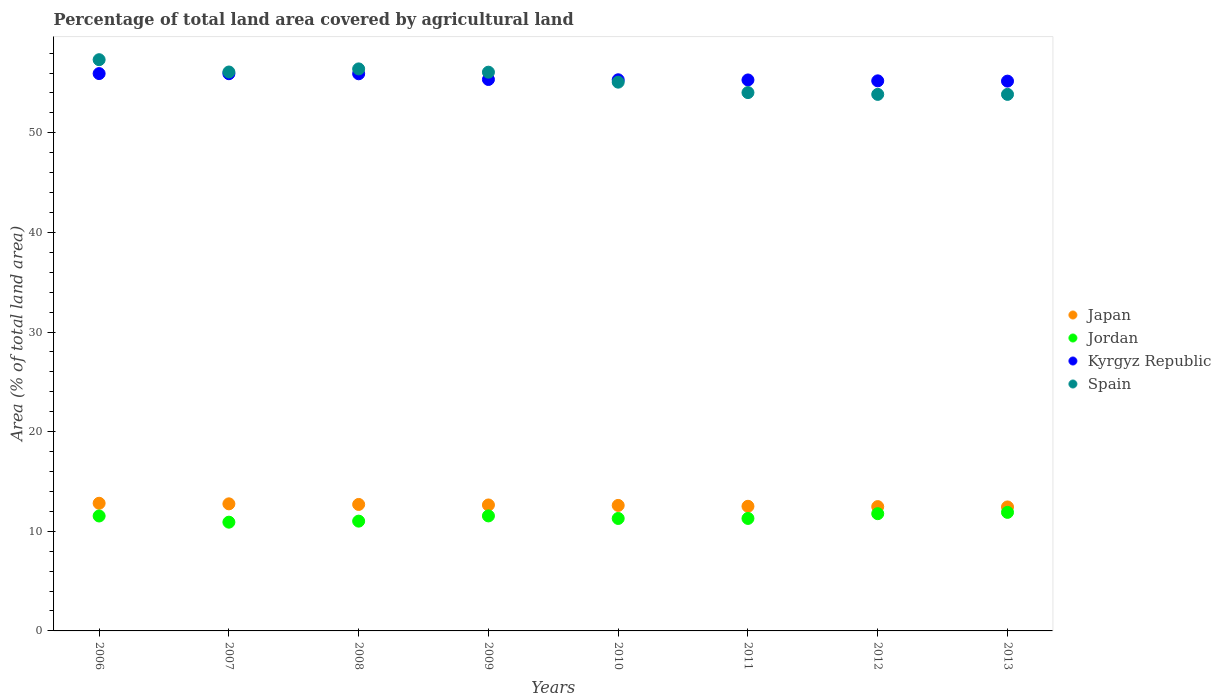Is the number of dotlines equal to the number of legend labels?
Offer a terse response. Yes. What is the percentage of agricultural land in Jordan in 2009?
Your response must be concise. 11.55. Across all years, what is the maximum percentage of agricultural land in Spain?
Ensure brevity in your answer.  57.34. Across all years, what is the minimum percentage of agricultural land in Japan?
Offer a very short reply. 12.45. In which year was the percentage of agricultural land in Jordan maximum?
Offer a terse response. 2013. In which year was the percentage of agricultural land in Jordan minimum?
Provide a short and direct response. 2007. What is the total percentage of agricultural land in Jordan in the graph?
Your response must be concise. 91.27. What is the difference between the percentage of agricultural land in Kyrgyz Republic in 2009 and that in 2012?
Your response must be concise. 0.14. What is the difference between the percentage of agricultural land in Jordan in 2011 and the percentage of agricultural land in Spain in 2008?
Offer a terse response. -45.13. What is the average percentage of agricultural land in Jordan per year?
Offer a terse response. 11.41. In the year 2007, what is the difference between the percentage of agricultural land in Spain and percentage of agricultural land in Jordan?
Offer a terse response. 45.19. In how many years, is the percentage of agricultural land in Jordan greater than 18 %?
Offer a terse response. 0. What is the ratio of the percentage of agricultural land in Jordan in 2009 to that in 2012?
Provide a succinct answer. 0.98. Is the percentage of agricultural land in Jordan in 2011 less than that in 2012?
Provide a succinct answer. Yes. Is the difference between the percentage of agricultural land in Spain in 2010 and 2012 greater than the difference between the percentage of agricultural land in Jordan in 2010 and 2012?
Offer a very short reply. Yes. What is the difference between the highest and the second highest percentage of agricultural land in Kyrgyz Republic?
Offer a very short reply. 0.01. What is the difference between the highest and the lowest percentage of agricultural land in Japan?
Provide a short and direct response. 0.37. Is it the case that in every year, the sum of the percentage of agricultural land in Jordan and percentage of agricultural land in Spain  is greater than the percentage of agricultural land in Kyrgyz Republic?
Offer a very short reply. Yes. Does the percentage of agricultural land in Jordan monotonically increase over the years?
Your answer should be very brief. No. Is the percentage of agricultural land in Spain strictly less than the percentage of agricultural land in Japan over the years?
Provide a succinct answer. No. How many years are there in the graph?
Offer a terse response. 8. Does the graph contain grids?
Your answer should be very brief. No. What is the title of the graph?
Make the answer very short. Percentage of total land area covered by agricultural land. Does "Seychelles" appear as one of the legend labels in the graph?
Give a very brief answer. No. What is the label or title of the Y-axis?
Make the answer very short. Area (% of total land area). What is the Area (% of total land area) of Japan in 2006?
Give a very brief answer. 12.81. What is the Area (% of total land area) of Jordan in 2006?
Offer a very short reply. 11.54. What is the Area (% of total land area) in Kyrgyz Republic in 2006?
Provide a succinct answer. 55.95. What is the Area (% of total land area) in Spain in 2006?
Provide a succinct answer. 57.34. What is the Area (% of total land area) of Japan in 2007?
Make the answer very short. 12.76. What is the Area (% of total land area) of Jordan in 2007?
Offer a terse response. 10.92. What is the Area (% of total land area) of Kyrgyz Republic in 2007?
Your answer should be compact. 55.94. What is the Area (% of total land area) of Spain in 2007?
Provide a succinct answer. 56.11. What is the Area (% of total land area) of Japan in 2008?
Your answer should be very brief. 12.7. What is the Area (% of total land area) of Jordan in 2008?
Your response must be concise. 11.02. What is the Area (% of total land area) in Kyrgyz Republic in 2008?
Provide a short and direct response. 55.93. What is the Area (% of total land area) in Spain in 2008?
Give a very brief answer. 56.42. What is the Area (% of total land area) of Japan in 2009?
Provide a succinct answer. 12.64. What is the Area (% of total land area) of Jordan in 2009?
Ensure brevity in your answer.  11.55. What is the Area (% of total land area) of Kyrgyz Republic in 2009?
Ensure brevity in your answer.  55.36. What is the Area (% of total land area) of Spain in 2009?
Your answer should be compact. 56.09. What is the Area (% of total land area) in Japan in 2010?
Give a very brief answer. 12.6. What is the Area (% of total land area) in Jordan in 2010?
Provide a succinct answer. 11.29. What is the Area (% of total land area) in Kyrgyz Republic in 2010?
Give a very brief answer. 55.33. What is the Area (% of total land area) of Spain in 2010?
Make the answer very short. 55.09. What is the Area (% of total land area) in Japan in 2011?
Your answer should be compact. 12.51. What is the Area (% of total land area) of Jordan in 2011?
Your response must be concise. 11.29. What is the Area (% of total land area) in Kyrgyz Republic in 2011?
Your answer should be very brief. 55.31. What is the Area (% of total land area) of Spain in 2011?
Provide a short and direct response. 54.04. What is the Area (% of total land area) in Japan in 2012?
Your answer should be compact. 12.48. What is the Area (% of total land area) of Jordan in 2012?
Your answer should be compact. 11.77. What is the Area (% of total land area) of Kyrgyz Republic in 2012?
Provide a short and direct response. 55.22. What is the Area (% of total land area) of Spain in 2012?
Offer a terse response. 53.86. What is the Area (% of total land area) of Japan in 2013?
Offer a terse response. 12.45. What is the Area (% of total land area) in Jordan in 2013?
Keep it short and to the point. 11.9. What is the Area (% of total land area) in Kyrgyz Republic in 2013?
Provide a short and direct response. 55.19. What is the Area (% of total land area) of Spain in 2013?
Your answer should be very brief. 53.86. Across all years, what is the maximum Area (% of total land area) of Japan?
Provide a succinct answer. 12.81. Across all years, what is the maximum Area (% of total land area) of Jordan?
Keep it short and to the point. 11.9. Across all years, what is the maximum Area (% of total land area) in Kyrgyz Republic?
Make the answer very short. 55.95. Across all years, what is the maximum Area (% of total land area) in Spain?
Offer a terse response. 57.34. Across all years, what is the minimum Area (% of total land area) in Japan?
Ensure brevity in your answer.  12.45. Across all years, what is the minimum Area (% of total land area) in Jordan?
Your response must be concise. 10.92. Across all years, what is the minimum Area (% of total land area) in Kyrgyz Republic?
Ensure brevity in your answer.  55.19. Across all years, what is the minimum Area (% of total land area) of Spain?
Your response must be concise. 53.86. What is the total Area (% of total land area) of Japan in the graph?
Offer a terse response. 100.95. What is the total Area (% of total land area) in Jordan in the graph?
Your answer should be very brief. 91.27. What is the total Area (% of total land area) of Kyrgyz Republic in the graph?
Offer a very short reply. 444.22. What is the total Area (% of total land area) in Spain in the graph?
Your answer should be compact. 442.81. What is the difference between the Area (% of total land area) in Japan in 2006 and that in 2007?
Provide a succinct answer. 0.06. What is the difference between the Area (% of total land area) in Jordan in 2006 and that in 2007?
Your answer should be compact. 0.62. What is the difference between the Area (% of total land area) of Kyrgyz Republic in 2006 and that in 2007?
Provide a short and direct response. 0.01. What is the difference between the Area (% of total land area) in Spain in 2006 and that in 2007?
Provide a succinct answer. 1.24. What is the difference between the Area (% of total land area) in Japan in 2006 and that in 2008?
Your response must be concise. 0.12. What is the difference between the Area (% of total land area) in Jordan in 2006 and that in 2008?
Keep it short and to the point. 0.52. What is the difference between the Area (% of total land area) of Kyrgyz Republic in 2006 and that in 2008?
Provide a short and direct response. 0.02. What is the difference between the Area (% of total land area) in Spain in 2006 and that in 2008?
Your response must be concise. 0.92. What is the difference between the Area (% of total land area) in Japan in 2006 and that in 2009?
Offer a terse response. 0.17. What is the difference between the Area (% of total land area) in Jordan in 2006 and that in 2009?
Your answer should be compact. -0.01. What is the difference between the Area (% of total land area) in Kyrgyz Republic in 2006 and that in 2009?
Give a very brief answer. 0.59. What is the difference between the Area (% of total land area) in Spain in 2006 and that in 2009?
Give a very brief answer. 1.25. What is the difference between the Area (% of total land area) of Japan in 2006 and that in 2010?
Offer a terse response. 0.22. What is the difference between the Area (% of total land area) of Jordan in 2006 and that in 2010?
Make the answer very short. 0.25. What is the difference between the Area (% of total land area) of Kyrgyz Republic in 2006 and that in 2010?
Offer a terse response. 0.62. What is the difference between the Area (% of total land area) in Spain in 2006 and that in 2010?
Provide a succinct answer. 2.25. What is the difference between the Area (% of total land area) of Japan in 2006 and that in 2011?
Your answer should be compact. 0.3. What is the difference between the Area (% of total land area) of Jordan in 2006 and that in 2011?
Keep it short and to the point. 0.24. What is the difference between the Area (% of total land area) in Kyrgyz Republic in 2006 and that in 2011?
Your response must be concise. 0.64. What is the difference between the Area (% of total land area) in Spain in 2006 and that in 2011?
Your answer should be very brief. 3.3. What is the difference between the Area (% of total land area) in Japan in 2006 and that in 2012?
Keep it short and to the point. 0.34. What is the difference between the Area (% of total land area) in Jordan in 2006 and that in 2012?
Keep it short and to the point. -0.23. What is the difference between the Area (% of total land area) of Kyrgyz Republic in 2006 and that in 2012?
Keep it short and to the point. 0.73. What is the difference between the Area (% of total land area) of Spain in 2006 and that in 2012?
Your answer should be very brief. 3.48. What is the difference between the Area (% of total land area) of Japan in 2006 and that in 2013?
Provide a short and direct response. 0.37. What is the difference between the Area (% of total land area) in Jordan in 2006 and that in 2013?
Offer a terse response. -0.36. What is the difference between the Area (% of total land area) of Kyrgyz Republic in 2006 and that in 2013?
Your answer should be compact. 0.76. What is the difference between the Area (% of total land area) in Spain in 2006 and that in 2013?
Offer a very short reply. 3.48. What is the difference between the Area (% of total land area) in Japan in 2007 and that in 2008?
Ensure brevity in your answer.  0.06. What is the difference between the Area (% of total land area) of Jordan in 2007 and that in 2008?
Keep it short and to the point. -0.1. What is the difference between the Area (% of total land area) in Kyrgyz Republic in 2007 and that in 2008?
Make the answer very short. 0.01. What is the difference between the Area (% of total land area) in Spain in 2007 and that in 2008?
Offer a terse response. -0.31. What is the difference between the Area (% of total land area) in Japan in 2007 and that in 2009?
Give a very brief answer. 0.11. What is the difference between the Area (% of total land area) in Jordan in 2007 and that in 2009?
Provide a short and direct response. -0.63. What is the difference between the Area (% of total land area) in Kyrgyz Republic in 2007 and that in 2009?
Your answer should be compact. 0.58. What is the difference between the Area (% of total land area) in Spain in 2007 and that in 2009?
Your answer should be compact. 0.02. What is the difference between the Area (% of total land area) in Japan in 2007 and that in 2010?
Your answer should be very brief. 0.16. What is the difference between the Area (% of total land area) of Jordan in 2007 and that in 2010?
Your answer should be very brief. -0.37. What is the difference between the Area (% of total land area) of Kyrgyz Republic in 2007 and that in 2010?
Offer a terse response. 0.61. What is the difference between the Area (% of total land area) of Japan in 2007 and that in 2011?
Your answer should be compact. 0.25. What is the difference between the Area (% of total land area) of Jordan in 2007 and that in 2011?
Your response must be concise. -0.38. What is the difference between the Area (% of total land area) of Kyrgyz Republic in 2007 and that in 2011?
Give a very brief answer. 0.63. What is the difference between the Area (% of total land area) in Spain in 2007 and that in 2011?
Your answer should be very brief. 2.07. What is the difference between the Area (% of total land area) in Japan in 2007 and that in 2012?
Provide a succinct answer. 0.28. What is the difference between the Area (% of total land area) of Jordan in 2007 and that in 2012?
Provide a short and direct response. -0.85. What is the difference between the Area (% of total land area) of Kyrgyz Republic in 2007 and that in 2012?
Your answer should be very brief. 0.72. What is the difference between the Area (% of total land area) in Spain in 2007 and that in 2012?
Give a very brief answer. 2.25. What is the difference between the Area (% of total land area) of Japan in 2007 and that in 2013?
Ensure brevity in your answer.  0.31. What is the difference between the Area (% of total land area) in Jordan in 2007 and that in 2013?
Provide a succinct answer. -0.98. What is the difference between the Area (% of total land area) in Kyrgyz Republic in 2007 and that in 2013?
Provide a short and direct response. 0.74. What is the difference between the Area (% of total land area) of Spain in 2007 and that in 2013?
Provide a short and direct response. 2.25. What is the difference between the Area (% of total land area) of Japan in 2008 and that in 2009?
Give a very brief answer. 0.05. What is the difference between the Area (% of total land area) of Jordan in 2008 and that in 2009?
Offer a terse response. -0.52. What is the difference between the Area (% of total land area) of Kyrgyz Republic in 2008 and that in 2009?
Offer a terse response. 0.57. What is the difference between the Area (% of total land area) in Spain in 2008 and that in 2009?
Provide a succinct answer. 0.33. What is the difference between the Area (% of total land area) of Japan in 2008 and that in 2010?
Offer a terse response. 0.1. What is the difference between the Area (% of total land area) of Jordan in 2008 and that in 2010?
Give a very brief answer. -0.27. What is the difference between the Area (% of total land area) of Kyrgyz Republic in 2008 and that in 2010?
Offer a terse response. 0.6. What is the difference between the Area (% of total land area) in Spain in 2008 and that in 2010?
Ensure brevity in your answer.  1.33. What is the difference between the Area (% of total land area) in Japan in 2008 and that in 2011?
Provide a succinct answer. 0.19. What is the difference between the Area (% of total land area) in Jordan in 2008 and that in 2011?
Provide a succinct answer. -0.27. What is the difference between the Area (% of total land area) of Kyrgyz Republic in 2008 and that in 2011?
Your answer should be very brief. 0.62. What is the difference between the Area (% of total land area) of Spain in 2008 and that in 2011?
Keep it short and to the point. 2.38. What is the difference between the Area (% of total land area) of Japan in 2008 and that in 2012?
Provide a short and direct response. 0.22. What is the difference between the Area (% of total land area) in Jordan in 2008 and that in 2012?
Offer a very short reply. -0.75. What is the difference between the Area (% of total land area) in Kyrgyz Republic in 2008 and that in 2012?
Your answer should be compact. 0.71. What is the difference between the Area (% of total land area) in Spain in 2008 and that in 2012?
Keep it short and to the point. 2.56. What is the difference between the Area (% of total land area) in Japan in 2008 and that in 2013?
Offer a very short reply. 0.25. What is the difference between the Area (% of total land area) in Jordan in 2008 and that in 2013?
Your answer should be compact. -0.88. What is the difference between the Area (% of total land area) of Kyrgyz Republic in 2008 and that in 2013?
Ensure brevity in your answer.  0.74. What is the difference between the Area (% of total land area) of Spain in 2008 and that in 2013?
Provide a short and direct response. 2.56. What is the difference between the Area (% of total land area) of Japan in 2009 and that in 2010?
Offer a terse response. 0.05. What is the difference between the Area (% of total land area) of Jordan in 2009 and that in 2010?
Give a very brief answer. 0.26. What is the difference between the Area (% of total land area) of Kyrgyz Republic in 2009 and that in 2010?
Offer a very short reply. 0.03. What is the difference between the Area (% of total land area) in Japan in 2009 and that in 2011?
Your answer should be compact. 0.13. What is the difference between the Area (% of total land area) in Jordan in 2009 and that in 2011?
Ensure brevity in your answer.  0.25. What is the difference between the Area (% of total land area) of Kyrgyz Republic in 2009 and that in 2011?
Provide a succinct answer. 0.05. What is the difference between the Area (% of total land area) in Spain in 2009 and that in 2011?
Your response must be concise. 2.05. What is the difference between the Area (% of total land area) in Japan in 2009 and that in 2012?
Give a very brief answer. 0.17. What is the difference between the Area (% of total land area) of Jordan in 2009 and that in 2012?
Offer a very short reply. -0.22. What is the difference between the Area (% of total land area) of Kyrgyz Republic in 2009 and that in 2012?
Provide a succinct answer. 0.14. What is the difference between the Area (% of total land area) in Spain in 2009 and that in 2012?
Provide a succinct answer. 2.23. What is the difference between the Area (% of total land area) of Japan in 2009 and that in 2013?
Your response must be concise. 0.2. What is the difference between the Area (% of total land area) in Jordan in 2009 and that in 2013?
Make the answer very short. -0.36. What is the difference between the Area (% of total land area) of Kyrgyz Republic in 2009 and that in 2013?
Your response must be concise. 0.16. What is the difference between the Area (% of total land area) of Spain in 2009 and that in 2013?
Provide a short and direct response. 2.23. What is the difference between the Area (% of total land area) of Japan in 2010 and that in 2011?
Your answer should be compact. 0.09. What is the difference between the Area (% of total land area) in Jordan in 2010 and that in 2011?
Give a very brief answer. -0. What is the difference between the Area (% of total land area) of Kyrgyz Republic in 2010 and that in 2011?
Keep it short and to the point. 0.02. What is the difference between the Area (% of total land area) in Spain in 2010 and that in 2011?
Your answer should be very brief. 1.05. What is the difference between the Area (% of total land area) of Japan in 2010 and that in 2012?
Offer a very short reply. 0.12. What is the difference between the Area (% of total land area) in Jordan in 2010 and that in 2012?
Offer a terse response. -0.48. What is the difference between the Area (% of total land area) in Kyrgyz Republic in 2010 and that in 2012?
Make the answer very short. 0.11. What is the difference between the Area (% of total land area) in Spain in 2010 and that in 2012?
Keep it short and to the point. 1.23. What is the difference between the Area (% of total land area) in Japan in 2010 and that in 2013?
Ensure brevity in your answer.  0.15. What is the difference between the Area (% of total land area) in Jordan in 2010 and that in 2013?
Your answer should be compact. -0.61. What is the difference between the Area (% of total land area) in Kyrgyz Republic in 2010 and that in 2013?
Keep it short and to the point. 0.14. What is the difference between the Area (% of total land area) in Spain in 2010 and that in 2013?
Offer a very short reply. 1.23. What is the difference between the Area (% of total land area) of Japan in 2011 and that in 2012?
Make the answer very short. 0.03. What is the difference between the Area (% of total land area) of Jordan in 2011 and that in 2012?
Make the answer very short. -0.48. What is the difference between the Area (% of total land area) in Kyrgyz Republic in 2011 and that in 2012?
Provide a succinct answer. 0.09. What is the difference between the Area (% of total land area) of Spain in 2011 and that in 2012?
Offer a terse response. 0.18. What is the difference between the Area (% of total land area) in Japan in 2011 and that in 2013?
Make the answer very short. 0.07. What is the difference between the Area (% of total land area) in Jordan in 2011 and that in 2013?
Offer a very short reply. -0.61. What is the difference between the Area (% of total land area) of Kyrgyz Republic in 2011 and that in 2013?
Offer a terse response. 0.12. What is the difference between the Area (% of total land area) in Spain in 2011 and that in 2013?
Ensure brevity in your answer.  0.18. What is the difference between the Area (% of total land area) of Japan in 2012 and that in 2013?
Your response must be concise. 0.03. What is the difference between the Area (% of total land area) in Jordan in 2012 and that in 2013?
Offer a terse response. -0.13. What is the difference between the Area (% of total land area) of Kyrgyz Republic in 2012 and that in 2013?
Keep it short and to the point. 0.03. What is the difference between the Area (% of total land area) in Japan in 2006 and the Area (% of total land area) in Jordan in 2007?
Offer a terse response. 1.9. What is the difference between the Area (% of total land area) of Japan in 2006 and the Area (% of total land area) of Kyrgyz Republic in 2007?
Your response must be concise. -43.12. What is the difference between the Area (% of total land area) in Japan in 2006 and the Area (% of total land area) in Spain in 2007?
Your answer should be very brief. -43.29. What is the difference between the Area (% of total land area) in Jordan in 2006 and the Area (% of total land area) in Kyrgyz Republic in 2007?
Provide a short and direct response. -44.4. What is the difference between the Area (% of total land area) of Jordan in 2006 and the Area (% of total land area) of Spain in 2007?
Your response must be concise. -44.57. What is the difference between the Area (% of total land area) of Kyrgyz Republic in 2006 and the Area (% of total land area) of Spain in 2007?
Give a very brief answer. -0.16. What is the difference between the Area (% of total land area) of Japan in 2006 and the Area (% of total land area) of Jordan in 2008?
Offer a terse response. 1.79. What is the difference between the Area (% of total land area) of Japan in 2006 and the Area (% of total land area) of Kyrgyz Republic in 2008?
Give a very brief answer. -43.11. What is the difference between the Area (% of total land area) in Japan in 2006 and the Area (% of total land area) in Spain in 2008?
Provide a short and direct response. -43.6. What is the difference between the Area (% of total land area) of Jordan in 2006 and the Area (% of total land area) of Kyrgyz Republic in 2008?
Ensure brevity in your answer.  -44.39. What is the difference between the Area (% of total land area) of Jordan in 2006 and the Area (% of total land area) of Spain in 2008?
Make the answer very short. -44.88. What is the difference between the Area (% of total land area) in Kyrgyz Republic in 2006 and the Area (% of total land area) in Spain in 2008?
Your response must be concise. -0.47. What is the difference between the Area (% of total land area) in Japan in 2006 and the Area (% of total land area) in Jordan in 2009?
Make the answer very short. 1.27. What is the difference between the Area (% of total land area) in Japan in 2006 and the Area (% of total land area) in Kyrgyz Republic in 2009?
Ensure brevity in your answer.  -42.54. What is the difference between the Area (% of total land area) of Japan in 2006 and the Area (% of total land area) of Spain in 2009?
Provide a succinct answer. -43.28. What is the difference between the Area (% of total land area) in Jordan in 2006 and the Area (% of total land area) in Kyrgyz Republic in 2009?
Provide a succinct answer. -43.82. What is the difference between the Area (% of total land area) in Jordan in 2006 and the Area (% of total land area) in Spain in 2009?
Your answer should be compact. -44.55. What is the difference between the Area (% of total land area) of Kyrgyz Republic in 2006 and the Area (% of total land area) of Spain in 2009?
Make the answer very short. -0.14. What is the difference between the Area (% of total land area) of Japan in 2006 and the Area (% of total land area) of Jordan in 2010?
Offer a very short reply. 1.53. What is the difference between the Area (% of total land area) in Japan in 2006 and the Area (% of total land area) in Kyrgyz Republic in 2010?
Provide a succinct answer. -42.51. What is the difference between the Area (% of total land area) in Japan in 2006 and the Area (% of total land area) in Spain in 2010?
Offer a very short reply. -42.27. What is the difference between the Area (% of total land area) of Jordan in 2006 and the Area (% of total land area) of Kyrgyz Republic in 2010?
Ensure brevity in your answer.  -43.79. What is the difference between the Area (% of total land area) in Jordan in 2006 and the Area (% of total land area) in Spain in 2010?
Offer a terse response. -43.55. What is the difference between the Area (% of total land area) of Kyrgyz Republic in 2006 and the Area (% of total land area) of Spain in 2010?
Offer a very short reply. 0.86. What is the difference between the Area (% of total land area) of Japan in 2006 and the Area (% of total land area) of Jordan in 2011?
Make the answer very short. 1.52. What is the difference between the Area (% of total land area) in Japan in 2006 and the Area (% of total land area) in Kyrgyz Republic in 2011?
Make the answer very short. -42.5. What is the difference between the Area (% of total land area) in Japan in 2006 and the Area (% of total land area) in Spain in 2011?
Offer a terse response. -41.23. What is the difference between the Area (% of total land area) of Jordan in 2006 and the Area (% of total land area) of Kyrgyz Republic in 2011?
Make the answer very short. -43.77. What is the difference between the Area (% of total land area) in Jordan in 2006 and the Area (% of total land area) in Spain in 2011?
Provide a succinct answer. -42.5. What is the difference between the Area (% of total land area) in Kyrgyz Republic in 2006 and the Area (% of total land area) in Spain in 2011?
Provide a short and direct response. 1.91. What is the difference between the Area (% of total land area) in Japan in 2006 and the Area (% of total land area) in Jordan in 2012?
Your answer should be compact. 1.05. What is the difference between the Area (% of total land area) in Japan in 2006 and the Area (% of total land area) in Kyrgyz Republic in 2012?
Give a very brief answer. -42.41. What is the difference between the Area (% of total land area) in Japan in 2006 and the Area (% of total land area) in Spain in 2012?
Give a very brief answer. -41.05. What is the difference between the Area (% of total land area) of Jordan in 2006 and the Area (% of total land area) of Kyrgyz Republic in 2012?
Give a very brief answer. -43.68. What is the difference between the Area (% of total land area) in Jordan in 2006 and the Area (% of total land area) in Spain in 2012?
Your answer should be compact. -42.32. What is the difference between the Area (% of total land area) in Kyrgyz Republic in 2006 and the Area (% of total land area) in Spain in 2012?
Give a very brief answer. 2.09. What is the difference between the Area (% of total land area) of Japan in 2006 and the Area (% of total land area) of Jordan in 2013?
Offer a very short reply. 0.91. What is the difference between the Area (% of total land area) of Japan in 2006 and the Area (% of total land area) of Kyrgyz Republic in 2013?
Give a very brief answer. -42.38. What is the difference between the Area (% of total land area) in Japan in 2006 and the Area (% of total land area) in Spain in 2013?
Give a very brief answer. -41.05. What is the difference between the Area (% of total land area) of Jordan in 2006 and the Area (% of total land area) of Kyrgyz Republic in 2013?
Provide a succinct answer. -43.66. What is the difference between the Area (% of total land area) in Jordan in 2006 and the Area (% of total land area) in Spain in 2013?
Give a very brief answer. -42.32. What is the difference between the Area (% of total land area) of Kyrgyz Republic in 2006 and the Area (% of total land area) of Spain in 2013?
Keep it short and to the point. 2.09. What is the difference between the Area (% of total land area) in Japan in 2007 and the Area (% of total land area) in Jordan in 2008?
Provide a short and direct response. 1.74. What is the difference between the Area (% of total land area) of Japan in 2007 and the Area (% of total land area) of Kyrgyz Republic in 2008?
Offer a very short reply. -43.17. What is the difference between the Area (% of total land area) of Japan in 2007 and the Area (% of total land area) of Spain in 2008?
Give a very brief answer. -43.66. What is the difference between the Area (% of total land area) in Jordan in 2007 and the Area (% of total land area) in Kyrgyz Republic in 2008?
Give a very brief answer. -45.01. What is the difference between the Area (% of total land area) of Jordan in 2007 and the Area (% of total land area) of Spain in 2008?
Give a very brief answer. -45.5. What is the difference between the Area (% of total land area) of Kyrgyz Republic in 2007 and the Area (% of total land area) of Spain in 2008?
Offer a very short reply. -0.48. What is the difference between the Area (% of total land area) in Japan in 2007 and the Area (% of total land area) in Jordan in 2009?
Your answer should be very brief. 1.21. What is the difference between the Area (% of total land area) in Japan in 2007 and the Area (% of total land area) in Kyrgyz Republic in 2009?
Provide a short and direct response. -42.6. What is the difference between the Area (% of total land area) in Japan in 2007 and the Area (% of total land area) in Spain in 2009?
Offer a very short reply. -43.33. What is the difference between the Area (% of total land area) in Jordan in 2007 and the Area (% of total land area) in Kyrgyz Republic in 2009?
Your answer should be compact. -44.44. What is the difference between the Area (% of total land area) of Jordan in 2007 and the Area (% of total land area) of Spain in 2009?
Ensure brevity in your answer.  -45.17. What is the difference between the Area (% of total land area) in Kyrgyz Republic in 2007 and the Area (% of total land area) in Spain in 2009?
Offer a very short reply. -0.15. What is the difference between the Area (% of total land area) in Japan in 2007 and the Area (% of total land area) in Jordan in 2010?
Offer a very short reply. 1.47. What is the difference between the Area (% of total land area) of Japan in 2007 and the Area (% of total land area) of Kyrgyz Republic in 2010?
Your answer should be compact. -42.57. What is the difference between the Area (% of total land area) in Japan in 2007 and the Area (% of total land area) in Spain in 2010?
Provide a succinct answer. -42.33. What is the difference between the Area (% of total land area) in Jordan in 2007 and the Area (% of total land area) in Kyrgyz Republic in 2010?
Your answer should be compact. -44.41. What is the difference between the Area (% of total land area) of Jordan in 2007 and the Area (% of total land area) of Spain in 2010?
Provide a short and direct response. -44.17. What is the difference between the Area (% of total land area) of Kyrgyz Republic in 2007 and the Area (% of total land area) of Spain in 2010?
Provide a short and direct response. 0.85. What is the difference between the Area (% of total land area) of Japan in 2007 and the Area (% of total land area) of Jordan in 2011?
Your answer should be compact. 1.46. What is the difference between the Area (% of total land area) of Japan in 2007 and the Area (% of total land area) of Kyrgyz Republic in 2011?
Offer a very short reply. -42.55. What is the difference between the Area (% of total land area) in Japan in 2007 and the Area (% of total land area) in Spain in 2011?
Provide a short and direct response. -41.28. What is the difference between the Area (% of total land area) of Jordan in 2007 and the Area (% of total land area) of Kyrgyz Republic in 2011?
Ensure brevity in your answer.  -44.39. What is the difference between the Area (% of total land area) of Jordan in 2007 and the Area (% of total land area) of Spain in 2011?
Your answer should be very brief. -43.12. What is the difference between the Area (% of total land area) of Kyrgyz Republic in 2007 and the Area (% of total land area) of Spain in 2011?
Ensure brevity in your answer.  1.9. What is the difference between the Area (% of total land area) in Japan in 2007 and the Area (% of total land area) in Kyrgyz Republic in 2012?
Offer a terse response. -42.46. What is the difference between the Area (% of total land area) of Japan in 2007 and the Area (% of total land area) of Spain in 2012?
Your answer should be very brief. -41.1. What is the difference between the Area (% of total land area) in Jordan in 2007 and the Area (% of total land area) in Kyrgyz Republic in 2012?
Your answer should be compact. -44.3. What is the difference between the Area (% of total land area) in Jordan in 2007 and the Area (% of total land area) in Spain in 2012?
Make the answer very short. -42.94. What is the difference between the Area (% of total land area) of Kyrgyz Republic in 2007 and the Area (% of total land area) of Spain in 2012?
Offer a very short reply. 2.08. What is the difference between the Area (% of total land area) of Japan in 2007 and the Area (% of total land area) of Jordan in 2013?
Offer a very short reply. 0.86. What is the difference between the Area (% of total land area) in Japan in 2007 and the Area (% of total land area) in Kyrgyz Republic in 2013?
Offer a terse response. -42.43. What is the difference between the Area (% of total land area) of Japan in 2007 and the Area (% of total land area) of Spain in 2013?
Ensure brevity in your answer.  -41.1. What is the difference between the Area (% of total land area) in Jordan in 2007 and the Area (% of total land area) in Kyrgyz Republic in 2013?
Provide a short and direct response. -44.27. What is the difference between the Area (% of total land area) of Jordan in 2007 and the Area (% of total land area) of Spain in 2013?
Make the answer very short. -42.94. What is the difference between the Area (% of total land area) of Kyrgyz Republic in 2007 and the Area (% of total land area) of Spain in 2013?
Provide a short and direct response. 2.08. What is the difference between the Area (% of total land area) in Japan in 2008 and the Area (% of total land area) in Jordan in 2009?
Your answer should be compact. 1.15. What is the difference between the Area (% of total land area) in Japan in 2008 and the Area (% of total land area) in Kyrgyz Republic in 2009?
Provide a short and direct response. -42.66. What is the difference between the Area (% of total land area) in Japan in 2008 and the Area (% of total land area) in Spain in 2009?
Provide a short and direct response. -43.39. What is the difference between the Area (% of total land area) in Jordan in 2008 and the Area (% of total land area) in Kyrgyz Republic in 2009?
Offer a terse response. -44.34. What is the difference between the Area (% of total land area) in Jordan in 2008 and the Area (% of total land area) in Spain in 2009?
Give a very brief answer. -45.07. What is the difference between the Area (% of total land area) in Kyrgyz Republic in 2008 and the Area (% of total land area) in Spain in 2009?
Keep it short and to the point. -0.16. What is the difference between the Area (% of total land area) in Japan in 2008 and the Area (% of total land area) in Jordan in 2010?
Provide a succinct answer. 1.41. What is the difference between the Area (% of total land area) of Japan in 2008 and the Area (% of total land area) of Kyrgyz Republic in 2010?
Provide a succinct answer. -42.63. What is the difference between the Area (% of total land area) in Japan in 2008 and the Area (% of total land area) in Spain in 2010?
Keep it short and to the point. -42.39. What is the difference between the Area (% of total land area) of Jordan in 2008 and the Area (% of total land area) of Kyrgyz Republic in 2010?
Your answer should be very brief. -44.31. What is the difference between the Area (% of total land area) in Jordan in 2008 and the Area (% of total land area) in Spain in 2010?
Keep it short and to the point. -44.07. What is the difference between the Area (% of total land area) in Kyrgyz Republic in 2008 and the Area (% of total land area) in Spain in 2010?
Keep it short and to the point. 0.84. What is the difference between the Area (% of total land area) of Japan in 2008 and the Area (% of total land area) of Jordan in 2011?
Keep it short and to the point. 1.4. What is the difference between the Area (% of total land area) in Japan in 2008 and the Area (% of total land area) in Kyrgyz Republic in 2011?
Provide a short and direct response. -42.61. What is the difference between the Area (% of total land area) of Japan in 2008 and the Area (% of total land area) of Spain in 2011?
Keep it short and to the point. -41.34. What is the difference between the Area (% of total land area) in Jordan in 2008 and the Area (% of total land area) in Kyrgyz Republic in 2011?
Provide a succinct answer. -44.29. What is the difference between the Area (% of total land area) of Jordan in 2008 and the Area (% of total land area) of Spain in 2011?
Your response must be concise. -43.02. What is the difference between the Area (% of total land area) of Kyrgyz Republic in 2008 and the Area (% of total land area) of Spain in 2011?
Provide a succinct answer. 1.89. What is the difference between the Area (% of total land area) in Japan in 2008 and the Area (% of total land area) in Jordan in 2012?
Keep it short and to the point. 0.93. What is the difference between the Area (% of total land area) of Japan in 2008 and the Area (% of total land area) of Kyrgyz Republic in 2012?
Keep it short and to the point. -42.52. What is the difference between the Area (% of total land area) in Japan in 2008 and the Area (% of total land area) in Spain in 2012?
Offer a very short reply. -41.16. What is the difference between the Area (% of total land area) in Jordan in 2008 and the Area (% of total land area) in Kyrgyz Republic in 2012?
Offer a terse response. -44.2. What is the difference between the Area (% of total land area) in Jordan in 2008 and the Area (% of total land area) in Spain in 2012?
Provide a short and direct response. -42.84. What is the difference between the Area (% of total land area) in Kyrgyz Republic in 2008 and the Area (% of total land area) in Spain in 2012?
Make the answer very short. 2.07. What is the difference between the Area (% of total land area) in Japan in 2008 and the Area (% of total land area) in Jordan in 2013?
Give a very brief answer. 0.8. What is the difference between the Area (% of total land area) in Japan in 2008 and the Area (% of total land area) in Kyrgyz Republic in 2013?
Provide a short and direct response. -42.49. What is the difference between the Area (% of total land area) in Japan in 2008 and the Area (% of total land area) in Spain in 2013?
Keep it short and to the point. -41.16. What is the difference between the Area (% of total land area) of Jordan in 2008 and the Area (% of total land area) of Kyrgyz Republic in 2013?
Ensure brevity in your answer.  -44.17. What is the difference between the Area (% of total land area) in Jordan in 2008 and the Area (% of total land area) in Spain in 2013?
Make the answer very short. -42.84. What is the difference between the Area (% of total land area) in Kyrgyz Republic in 2008 and the Area (% of total land area) in Spain in 2013?
Provide a short and direct response. 2.07. What is the difference between the Area (% of total land area) in Japan in 2009 and the Area (% of total land area) in Jordan in 2010?
Offer a terse response. 1.35. What is the difference between the Area (% of total land area) in Japan in 2009 and the Area (% of total land area) in Kyrgyz Republic in 2010?
Offer a terse response. -42.68. What is the difference between the Area (% of total land area) of Japan in 2009 and the Area (% of total land area) of Spain in 2010?
Offer a terse response. -42.44. What is the difference between the Area (% of total land area) of Jordan in 2009 and the Area (% of total land area) of Kyrgyz Republic in 2010?
Offer a very short reply. -43.78. What is the difference between the Area (% of total land area) of Jordan in 2009 and the Area (% of total land area) of Spain in 2010?
Offer a very short reply. -43.54. What is the difference between the Area (% of total land area) in Kyrgyz Republic in 2009 and the Area (% of total land area) in Spain in 2010?
Your answer should be compact. 0.27. What is the difference between the Area (% of total land area) of Japan in 2009 and the Area (% of total land area) of Jordan in 2011?
Offer a very short reply. 1.35. What is the difference between the Area (% of total land area) in Japan in 2009 and the Area (% of total land area) in Kyrgyz Republic in 2011?
Your answer should be very brief. -42.67. What is the difference between the Area (% of total land area) in Japan in 2009 and the Area (% of total land area) in Spain in 2011?
Your response must be concise. -41.4. What is the difference between the Area (% of total land area) in Jordan in 2009 and the Area (% of total land area) in Kyrgyz Republic in 2011?
Keep it short and to the point. -43.76. What is the difference between the Area (% of total land area) in Jordan in 2009 and the Area (% of total land area) in Spain in 2011?
Offer a very short reply. -42.5. What is the difference between the Area (% of total land area) of Kyrgyz Republic in 2009 and the Area (% of total land area) of Spain in 2011?
Provide a succinct answer. 1.32. What is the difference between the Area (% of total land area) in Japan in 2009 and the Area (% of total land area) in Jordan in 2012?
Your answer should be very brief. 0.88. What is the difference between the Area (% of total land area) in Japan in 2009 and the Area (% of total land area) in Kyrgyz Republic in 2012?
Make the answer very short. -42.58. What is the difference between the Area (% of total land area) of Japan in 2009 and the Area (% of total land area) of Spain in 2012?
Your response must be concise. -41.22. What is the difference between the Area (% of total land area) in Jordan in 2009 and the Area (% of total land area) in Kyrgyz Republic in 2012?
Provide a short and direct response. -43.68. What is the difference between the Area (% of total land area) of Jordan in 2009 and the Area (% of total land area) of Spain in 2012?
Your answer should be compact. -42.32. What is the difference between the Area (% of total land area) of Kyrgyz Republic in 2009 and the Area (% of total land area) of Spain in 2012?
Make the answer very short. 1.49. What is the difference between the Area (% of total land area) of Japan in 2009 and the Area (% of total land area) of Jordan in 2013?
Make the answer very short. 0.74. What is the difference between the Area (% of total land area) of Japan in 2009 and the Area (% of total land area) of Kyrgyz Republic in 2013?
Provide a succinct answer. -42.55. What is the difference between the Area (% of total land area) in Japan in 2009 and the Area (% of total land area) in Spain in 2013?
Your answer should be very brief. -41.22. What is the difference between the Area (% of total land area) of Jordan in 2009 and the Area (% of total land area) of Kyrgyz Republic in 2013?
Provide a short and direct response. -43.65. What is the difference between the Area (% of total land area) in Jordan in 2009 and the Area (% of total land area) in Spain in 2013?
Your answer should be compact. -42.32. What is the difference between the Area (% of total land area) in Kyrgyz Republic in 2009 and the Area (% of total land area) in Spain in 2013?
Provide a short and direct response. 1.49. What is the difference between the Area (% of total land area) of Japan in 2010 and the Area (% of total land area) of Jordan in 2011?
Ensure brevity in your answer.  1.31. What is the difference between the Area (% of total land area) of Japan in 2010 and the Area (% of total land area) of Kyrgyz Republic in 2011?
Keep it short and to the point. -42.71. What is the difference between the Area (% of total land area) in Japan in 2010 and the Area (% of total land area) in Spain in 2011?
Your response must be concise. -41.44. What is the difference between the Area (% of total land area) of Jordan in 2010 and the Area (% of total land area) of Kyrgyz Republic in 2011?
Keep it short and to the point. -44.02. What is the difference between the Area (% of total land area) in Jordan in 2010 and the Area (% of total land area) in Spain in 2011?
Provide a short and direct response. -42.75. What is the difference between the Area (% of total land area) of Kyrgyz Republic in 2010 and the Area (% of total land area) of Spain in 2011?
Give a very brief answer. 1.29. What is the difference between the Area (% of total land area) of Japan in 2010 and the Area (% of total land area) of Jordan in 2012?
Keep it short and to the point. 0.83. What is the difference between the Area (% of total land area) in Japan in 2010 and the Area (% of total land area) in Kyrgyz Republic in 2012?
Keep it short and to the point. -42.62. What is the difference between the Area (% of total land area) of Japan in 2010 and the Area (% of total land area) of Spain in 2012?
Keep it short and to the point. -41.26. What is the difference between the Area (% of total land area) of Jordan in 2010 and the Area (% of total land area) of Kyrgyz Republic in 2012?
Offer a very short reply. -43.93. What is the difference between the Area (% of total land area) in Jordan in 2010 and the Area (% of total land area) in Spain in 2012?
Your answer should be very brief. -42.57. What is the difference between the Area (% of total land area) of Kyrgyz Republic in 2010 and the Area (% of total land area) of Spain in 2012?
Offer a very short reply. 1.47. What is the difference between the Area (% of total land area) of Japan in 2010 and the Area (% of total land area) of Jordan in 2013?
Your answer should be compact. 0.7. What is the difference between the Area (% of total land area) of Japan in 2010 and the Area (% of total land area) of Kyrgyz Republic in 2013?
Provide a short and direct response. -42.59. What is the difference between the Area (% of total land area) of Japan in 2010 and the Area (% of total land area) of Spain in 2013?
Your answer should be very brief. -41.26. What is the difference between the Area (% of total land area) in Jordan in 2010 and the Area (% of total land area) in Kyrgyz Republic in 2013?
Your answer should be very brief. -43.9. What is the difference between the Area (% of total land area) of Jordan in 2010 and the Area (% of total land area) of Spain in 2013?
Your answer should be very brief. -42.57. What is the difference between the Area (% of total land area) in Kyrgyz Republic in 2010 and the Area (% of total land area) in Spain in 2013?
Provide a short and direct response. 1.47. What is the difference between the Area (% of total land area) in Japan in 2011 and the Area (% of total land area) in Jordan in 2012?
Offer a very short reply. 0.74. What is the difference between the Area (% of total land area) of Japan in 2011 and the Area (% of total land area) of Kyrgyz Republic in 2012?
Offer a very short reply. -42.71. What is the difference between the Area (% of total land area) of Japan in 2011 and the Area (% of total land area) of Spain in 2012?
Keep it short and to the point. -41.35. What is the difference between the Area (% of total land area) of Jordan in 2011 and the Area (% of total land area) of Kyrgyz Republic in 2012?
Ensure brevity in your answer.  -43.93. What is the difference between the Area (% of total land area) of Jordan in 2011 and the Area (% of total land area) of Spain in 2012?
Provide a short and direct response. -42.57. What is the difference between the Area (% of total land area) of Kyrgyz Republic in 2011 and the Area (% of total land area) of Spain in 2012?
Give a very brief answer. 1.45. What is the difference between the Area (% of total land area) in Japan in 2011 and the Area (% of total land area) in Jordan in 2013?
Ensure brevity in your answer.  0.61. What is the difference between the Area (% of total land area) of Japan in 2011 and the Area (% of total land area) of Kyrgyz Republic in 2013?
Your answer should be very brief. -42.68. What is the difference between the Area (% of total land area) of Japan in 2011 and the Area (% of total land area) of Spain in 2013?
Offer a terse response. -41.35. What is the difference between the Area (% of total land area) in Jordan in 2011 and the Area (% of total land area) in Kyrgyz Republic in 2013?
Provide a succinct answer. -43.9. What is the difference between the Area (% of total land area) in Jordan in 2011 and the Area (% of total land area) in Spain in 2013?
Offer a very short reply. -42.57. What is the difference between the Area (% of total land area) in Kyrgyz Republic in 2011 and the Area (% of total land area) in Spain in 2013?
Provide a short and direct response. 1.45. What is the difference between the Area (% of total land area) of Japan in 2012 and the Area (% of total land area) of Jordan in 2013?
Make the answer very short. 0.58. What is the difference between the Area (% of total land area) of Japan in 2012 and the Area (% of total land area) of Kyrgyz Republic in 2013?
Offer a very short reply. -42.71. What is the difference between the Area (% of total land area) in Japan in 2012 and the Area (% of total land area) in Spain in 2013?
Provide a succinct answer. -41.38. What is the difference between the Area (% of total land area) in Jordan in 2012 and the Area (% of total land area) in Kyrgyz Republic in 2013?
Give a very brief answer. -43.42. What is the difference between the Area (% of total land area) in Jordan in 2012 and the Area (% of total land area) in Spain in 2013?
Your response must be concise. -42.09. What is the difference between the Area (% of total land area) in Kyrgyz Republic in 2012 and the Area (% of total land area) in Spain in 2013?
Ensure brevity in your answer.  1.36. What is the average Area (% of total land area) in Japan per year?
Offer a very short reply. 12.62. What is the average Area (% of total land area) of Jordan per year?
Your response must be concise. 11.41. What is the average Area (% of total land area) of Kyrgyz Republic per year?
Your answer should be very brief. 55.53. What is the average Area (% of total land area) in Spain per year?
Provide a short and direct response. 55.35. In the year 2006, what is the difference between the Area (% of total land area) in Japan and Area (% of total land area) in Jordan?
Ensure brevity in your answer.  1.28. In the year 2006, what is the difference between the Area (% of total land area) in Japan and Area (% of total land area) in Kyrgyz Republic?
Make the answer very short. -43.13. In the year 2006, what is the difference between the Area (% of total land area) in Japan and Area (% of total land area) in Spain?
Keep it short and to the point. -44.53. In the year 2006, what is the difference between the Area (% of total land area) of Jordan and Area (% of total land area) of Kyrgyz Republic?
Give a very brief answer. -44.41. In the year 2006, what is the difference between the Area (% of total land area) of Jordan and Area (% of total land area) of Spain?
Your answer should be very brief. -45.81. In the year 2006, what is the difference between the Area (% of total land area) in Kyrgyz Republic and Area (% of total land area) in Spain?
Give a very brief answer. -1.39. In the year 2007, what is the difference between the Area (% of total land area) of Japan and Area (% of total land area) of Jordan?
Your answer should be compact. 1.84. In the year 2007, what is the difference between the Area (% of total land area) of Japan and Area (% of total land area) of Kyrgyz Republic?
Offer a terse response. -43.18. In the year 2007, what is the difference between the Area (% of total land area) of Japan and Area (% of total land area) of Spain?
Make the answer very short. -43.35. In the year 2007, what is the difference between the Area (% of total land area) of Jordan and Area (% of total land area) of Kyrgyz Republic?
Your answer should be very brief. -45.02. In the year 2007, what is the difference between the Area (% of total land area) in Jordan and Area (% of total land area) in Spain?
Make the answer very short. -45.19. In the year 2007, what is the difference between the Area (% of total land area) in Kyrgyz Republic and Area (% of total land area) in Spain?
Your answer should be compact. -0.17. In the year 2008, what is the difference between the Area (% of total land area) in Japan and Area (% of total land area) in Jordan?
Give a very brief answer. 1.68. In the year 2008, what is the difference between the Area (% of total land area) in Japan and Area (% of total land area) in Kyrgyz Republic?
Your answer should be very brief. -43.23. In the year 2008, what is the difference between the Area (% of total land area) of Japan and Area (% of total land area) of Spain?
Your response must be concise. -43.72. In the year 2008, what is the difference between the Area (% of total land area) of Jordan and Area (% of total land area) of Kyrgyz Republic?
Provide a short and direct response. -44.91. In the year 2008, what is the difference between the Area (% of total land area) in Jordan and Area (% of total land area) in Spain?
Give a very brief answer. -45.4. In the year 2008, what is the difference between the Area (% of total land area) of Kyrgyz Republic and Area (% of total land area) of Spain?
Provide a succinct answer. -0.49. In the year 2009, what is the difference between the Area (% of total land area) of Japan and Area (% of total land area) of Jordan?
Keep it short and to the point. 1.1. In the year 2009, what is the difference between the Area (% of total land area) in Japan and Area (% of total land area) in Kyrgyz Republic?
Make the answer very short. -42.71. In the year 2009, what is the difference between the Area (% of total land area) of Japan and Area (% of total land area) of Spain?
Your answer should be very brief. -43.45. In the year 2009, what is the difference between the Area (% of total land area) of Jordan and Area (% of total land area) of Kyrgyz Republic?
Ensure brevity in your answer.  -43.81. In the year 2009, what is the difference between the Area (% of total land area) in Jordan and Area (% of total land area) in Spain?
Your answer should be very brief. -44.54. In the year 2009, what is the difference between the Area (% of total land area) in Kyrgyz Republic and Area (% of total land area) in Spain?
Make the answer very short. -0.73. In the year 2010, what is the difference between the Area (% of total land area) in Japan and Area (% of total land area) in Jordan?
Offer a terse response. 1.31. In the year 2010, what is the difference between the Area (% of total land area) in Japan and Area (% of total land area) in Kyrgyz Republic?
Your answer should be very brief. -42.73. In the year 2010, what is the difference between the Area (% of total land area) of Japan and Area (% of total land area) of Spain?
Provide a short and direct response. -42.49. In the year 2010, what is the difference between the Area (% of total land area) in Jordan and Area (% of total land area) in Kyrgyz Republic?
Your response must be concise. -44.04. In the year 2010, what is the difference between the Area (% of total land area) in Jordan and Area (% of total land area) in Spain?
Ensure brevity in your answer.  -43.8. In the year 2010, what is the difference between the Area (% of total land area) in Kyrgyz Republic and Area (% of total land area) in Spain?
Offer a terse response. 0.24. In the year 2011, what is the difference between the Area (% of total land area) of Japan and Area (% of total land area) of Jordan?
Provide a short and direct response. 1.22. In the year 2011, what is the difference between the Area (% of total land area) in Japan and Area (% of total land area) in Kyrgyz Republic?
Offer a very short reply. -42.8. In the year 2011, what is the difference between the Area (% of total land area) in Japan and Area (% of total land area) in Spain?
Keep it short and to the point. -41.53. In the year 2011, what is the difference between the Area (% of total land area) of Jordan and Area (% of total land area) of Kyrgyz Republic?
Your response must be concise. -44.02. In the year 2011, what is the difference between the Area (% of total land area) of Jordan and Area (% of total land area) of Spain?
Offer a terse response. -42.75. In the year 2011, what is the difference between the Area (% of total land area) of Kyrgyz Republic and Area (% of total land area) of Spain?
Offer a terse response. 1.27. In the year 2012, what is the difference between the Area (% of total land area) of Japan and Area (% of total land area) of Jordan?
Keep it short and to the point. 0.71. In the year 2012, what is the difference between the Area (% of total land area) in Japan and Area (% of total land area) in Kyrgyz Republic?
Your answer should be very brief. -42.74. In the year 2012, what is the difference between the Area (% of total land area) of Japan and Area (% of total land area) of Spain?
Ensure brevity in your answer.  -41.38. In the year 2012, what is the difference between the Area (% of total land area) of Jordan and Area (% of total land area) of Kyrgyz Republic?
Provide a succinct answer. -43.45. In the year 2012, what is the difference between the Area (% of total land area) in Jordan and Area (% of total land area) in Spain?
Provide a short and direct response. -42.09. In the year 2012, what is the difference between the Area (% of total land area) in Kyrgyz Republic and Area (% of total land area) in Spain?
Make the answer very short. 1.36. In the year 2013, what is the difference between the Area (% of total land area) of Japan and Area (% of total land area) of Jordan?
Your answer should be very brief. 0.54. In the year 2013, what is the difference between the Area (% of total land area) of Japan and Area (% of total land area) of Kyrgyz Republic?
Give a very brief answer. -42.75. In the year 2013, what is the difference between the Area (% of total land area) in Japan and Area (% of total land area) in Spain?
Keep it short and to the point. -41.42. In the year 2013, what is the difference between the Area (% of total land area) of Jordan and Area (% of total land area) of Kyrgyz Republic?
Give a very brief answer. -43.29. In the year 2013, what is the difference between the Area (% of total land area) of Jordan and Area (% of total land area) of Spain?
Give a very brief answer. -41.96. In the year 2013, what is the difference between the Area (% of total land area) in Kyrgyz Republic and Area (% of total land area) in Spain?
Ensure brevity in your answer.  1.33. What is the ratio of the Area (% of total land area) of Japan in 2006 to that in 2007?
Ensure brevity in your answer.  1. What is the ratio of the Area (% of total land area) in Jordan in 2006 to that in 2007?
Provide a short and direct response. 1.06. What is the ratio of the Area (% of total land area) in Japan in 2006 to that in 2008?
Give a very brief answer. 1.01. What is the ratio of the Area (% of total land area) in Jordan in 2006 to that in 2008?
Ensure brevity in your answer.  1.05. What is the ratio of the Area (% of total land area) of Spain in 2006 to that in 2008?
Offer a very short reply. 1.02. What is the ratio of the Area (% of total land area) in Japan in 2006 to that in 2009?
Keep it short and to the point. 1.01. What is the ratio of the Area (% of total land area) of Jordan in 2006 to that in 2009?
Offer a very short reply. 1. What is the ratio of the Area (% of total land area) in Kyrgyz Republic in 2006 to that in 2009?
Your answer should be compact. 1.01. What is the ratio of the Area (% of total land area) in Spain in 2006 to that in 2009?
Provide a short and direct response. 1.02. What is the ratio of the Area (% of total land area) of Japan in 2006 to that in 2010?
Your answer should be very brief. 1.02. What is the ratio of the Area (% of total land area) in Jordan in 2006 to that in 2010?
Keep it short and to the point. 1.02. What is the ratio of the Area (% of total land area) of Kyrgyz Republic in 2006 to that in 2010?
Offer a very short reply. 1.01. What is the ratio of the Area (% of total land area) in Spain in 2006 to that in 2010?
Offer a very short reply. 1.04. What is the ratio of the Area (% of total land area) of Japan in 2006 to that in 2011?
Your answer should be compact. 1.02. What is the ratio of the Area (% of total land area) of Jordan in 2006 to that in 2011?
Offer a terse response. 1.02. What is the ratio of the Area (% of total land area) in Kyrgyz Republic in 2006 to that in 2011?
Your answer should be compact. 1.01. What is the ratio of the Area (% of total land area) of Spain in 2006 to that in 2011?
Offer a terse response. 1.06. What is the ratio of the Area (% of total land area) in Jordan in 2006 to that in 2012?
Ensure brevity in your answer.  0.98. What is the ratio of the Area (% of total land area) in Kyrgyz Republic in 2006 to that in 2012?
Give a very brief answer. 1.01. What is the ratio of the Area (% of total land area) of Spain in 2006 to that in 2012?
Provide a succinct answer. 1.06. What is the ratio of the Area (% of total land area) of Japan in 2006 to that in 2013?
Provide a short and direct response. 1.03. What is the ratio of the Area (% of total land area) of Jordan in 2006 to that in 2013?
Your response must be concise. 0.97. What is the ratio of the Area (% of total land area) of Kyrgyz Republic in 2006 to that in 2013?
Give a very brief answer. 1.01. What is the ratio of the Area (% of total land area) of Spain in 2006 to that in 2013?
Provide a short and direct response. 1.06. What is the ratio of the Area (% of total land area) of Japan in 2007 to that in 2009?
Your answer should be very brief. 1.01. What is the ratio of the Area (% of total land area) of Jordan in 2007 to that in 2009?
Make the answer very short. 0.95. What is the ratio of the Area (% of total land area) of Kyrgyz Republic in 2007 to that in 2009?
Make the answer very short. 1.01. What is the ratio of the Area (% of total land area) in Spain in 2007 to that in 2009?
Ensure brevity in your answer.  1. What is the ratio of the Area (% of total land area) of Japan in 2007 to that in 2010?
Make the answer very short. 1.01. What is the ratio of the Area (% of total land area) of Jordan in 2007 to that in 2010?
Make the answer very short. 0.97. What is the ratio of the Area (% of total land area) in Kyrgyz Republic in 2007 to that in 2010?
Offer a very short reply. 1.01. What is the ratio of the Area (% of total land area) of Spain in 2007 to that in 2010?
Ensure brevity in your answer.  1.02. What is the ratio of the Area (% of total land area) in Japan in 2007 to that in 2011?
Provide a succinct answer. 1.02. What is the ratio of the Area (% of total land area) of Jordan in 2007 to that in 2011?
Give a very brief answer. 0.97. What is the ratio of the Area (% of total land area) of Kyrgyz Republic in 2007 to that in 2011?
Provide a short and direct response. 1.01. What is the ratio of the Area (% of total land area) of Spain in 2007 to that in 2011?
Ensure brevity in your answer.  1.04. What is the ratio of the Area (% of total land area) in Japan in 2007 to that in 2012?
Make the answer very short. 1.02. What is the ratio of the Area (% of total land area) in Jordan in 2007 to that in 2012?
Provide a succinct answer. 0.93. What is the ratio of the Area (% of total land area) of Kyrgyz Republic in 2007 to that in 2012?
Your answer should be very brief. 1.01. What is the ratio of the Area (% of total land area) in Spain in 2007 to that in 2012?
Ensure brevity in your answer.  1.04. What is the ratio of the Area (% of total land area) in Japan in 2007 to that in 2013?
Give a very brief answer. 1.03. What is the ratio of the Area (% of total land area) in Jordan in 2007 to that in 2013?
Keep it short and to the point. 0.92. What is the ratio of the Area (% of total land area) in Kyrgyz Republic in 2007 to that in 2013?
Provide a short and direct response. 1.01. What is the ratio of the Area (% of total land area) of Spain in 2007 to that in 2013?
Your response must be concise. 1.04. What is the ratio of the Area (% of total land area) of Japan in 2008 to that in 2009?
Make the answer very short. 1. What is the ratio of the Area (% of total land area) in Jordan in 2008 to that in 2009?
Provide a succinct answer. 0.95. What is the ratio of the Area (% of total land area) in Kyrgyz Republic in 2008 to that in 2009?
Ensure brevity in your answer.  1.01. What is the ratio of the Area (% of total land area) of Spain in 2008 to that in 2009?
Offer a very short reply. 1.01. What is the ratio of the Area (% of total land area) in Jordan in 2008 to that in 2010?
Offer a terse response. 0.98. What is the ratio of the Area (% of total land area) in Kyrgyz Republic in 2008 to that in 2010?
Offer a terse response. 1.01. What is the ratio of the Area (% of total land area) in Spain in 2008 to that in 2010?
Provide a short and direct response. 1.02. What is the ratio of the Area (% of total land area) of Japan in 2008 to that in 2011?
Your answer should be very brief. 1.01. What is the ratio of the Area (% of total land area) in Jordan in 2008 to that in 2011?
Provide a short and direct response. 0.98. What is the ratio of the Area (% of total land area) in Kyrgyz Republic in 2008 to that in 2011?
Offer a terse response. 1.01. What is the ratio of the Area (% of total land area) of Spain in 2008 to that in 2011?
Your response must be concise. 1.04. What is the ratio of the Area (% of total land area) of Japan in 2008 to that in 2012?
Provide a succinct answer. 1.02. What is the ratio of the Area (% of total land area) in Jordan in 2008 to that in 2012?
Your answer should be very brief. 0.94. What is the ratio of the Area (% of total land area) of Kyrgyz Republic in 2008 to that in 2012?
Provide a succinct answer. 1.01. What is the ratio of the Area (% of total land area) of Spain in 2008 to that in 2012?
Keep it short and to the point. 1.05. What is the ratio of the Area (% of total land area) in Japan in 2008 to that in 2013?
Offer a terse response. 1.02. What is the ratio of the Area (% of total land area) in Jordan in 2008 to that in 2013?
Offer a terse response. 0.93. What is the ratio of the Area (% of total land area) of Kyrgyz Republic in 2008 to that in 2013?
Keep it short and to the point. 1.01. What is the ratio of the Area (% of total land area) of Spain in 2008 to that in 2013?
Provide a short and direct response. 1.05. What is the ratio of the Area (% of total land area) of Japan in 2009 to that in 2010?
Your response must be concise. 1. What is the ratio of the Area (% of total land area) of Jordan in 2009 to that in 2010?
Your answer should be very brief. 1.02. What is the ratio of the Area (% of total land area) in Spain in 2009 to that in 2010?
Keep it short and to the point. 1.02. What is the ratio of the Area (% of total land area) in Japan in 2009 to that in 2011?
Make the answer very short. 1.01. What is the ratio of the Area (% of total land area) in Jordan in 2009 to that in 2011?
Offer a terse response. 1.02. What is the ratio of the Area (% of total land area) of Spain in 2009 to that in 2011?
Your answer should be very brief. 1.04. What is the ratio of the Area (% of total land area) in Japan in 2009 to that in 2012?
Offer a terse response. 1.01. What is the ratio of the Area (% of total land area) of Kyrgyz Republic in 2009 to that in 2012?
Provide a succinct answer. 1. What is the ratio of the Area (% of total land area) of Spain in 2009 to that in 2012?
Provide a short and direct response. 1.04. What is the ratio of the Area (% of total land area) of Japan in 2009 to that in 2013?
Provide a succinct answer. 1.02. What is the ratio of the Area (% of total land area) in Jordan in 2009 to that in 2013?
Your response must be concise. 0.97. What is the ratio of the Area (% of total land area) in Kyrgyz Republic in 2009 to that in 2013?
Ensure brevity in your answer.  1. What is the ratio of the Area (% of total land area) in Spain in 2009 to that in 2013?
Provide a short and direct response. 1.04. What is the ratio of the Area (% of total land area) of Japan in 2010 to that in 2011?
Give a very brief answer. 1.01. What is the ratio of the Area (% of total land area) of Jordan in 2010 to that in 2011?
Your response must be concise. 1. What is the ratio of the Area (% of total land area) in Kyrgyz Republic in 2010 to that in 2011?
Offer a terse response. 1. What is the ratio of the Area (% of total land area) of Spain in 2010 to that in 2011?
Ensure brevity in your answer.  1.02. What is the ratio of the Area (% of total land area) of Japan in 2010 to that in 2012?
Provide a short and direct response. 1.01. What is the ratio of the Area (% of total land area) in Jordan in 2010 to that in 2012?
Give a very brief answer. 0.96. What is the ratio of the Area (% of total land area) of Kyrgyz Republic in 2010 to that in 2012?
Provide a succinct answer. 1. What is the ratio of the Area (% of total land area) of Spain in 2010 to that in 2012?
Provide a short and direct response. 1.02. What is the ratio of the Area (% of total land area) of Japan in 2010 to that in 2013?
Your answer should be very brief. 1.01. What is the ratio of the Area (% of total land area) in Jordan in 2010 to that in 2013?
Your answer should be very brief. 0.95. What is the ratio of the Area (% of total land area) in Spain in 2010 to that in 2013?
Provide a succinct answer. 1.02. What is the ratio of the Area (% of total land area) of Jordan in 2011 to that in 2012?
Your answer should be very brief. 0.96. What is the ratio of the Area (% of total land area) in Spain in 2011 to that in 2012?
Ensure brevity in your answer.  1. What is the ratio of the Area (% of total land area) of Jordan in 2011 to that in 2013?
Ensure brevity in your answer.  0.95. What is the ratio of the Area (% of total land area) of Jordan in 2012 to that in 2013?
Your response must be concise. 0.99. What is the difference between the highest and the second highest Area (% of total land area) of Japan?
Offer a very short reply. 0.06. What is the difference between the highest and the second highest Area (% of total land area) in Jordan?
Make the answer very short. 0.13. What is the difference between the highest and the second highest Area (% of total land area) of Kyrgyz Republic?
Give a very brief answer. 0.01. What is the difference between the highest and the second highest Area (% of total land area) in Spain?
Give a very brief answer. 0.92. What is the difference between the highest and the lowest Area (% of total land area) in Japan?
Offer a terse response. 0.37. What is the difference between the highest and the lowest Area (% of total land area) of Jordan?
Provide a succinct answer. 0.98. What is the difference between the highest and the lowest Area (% of total land area) of Kyrgyz Republic?
Offer a terse response. 0.76. What is the difference between the highest and the lowest Area (% of total land area) of Spain?
Provide a succinct answer. 3.48. 